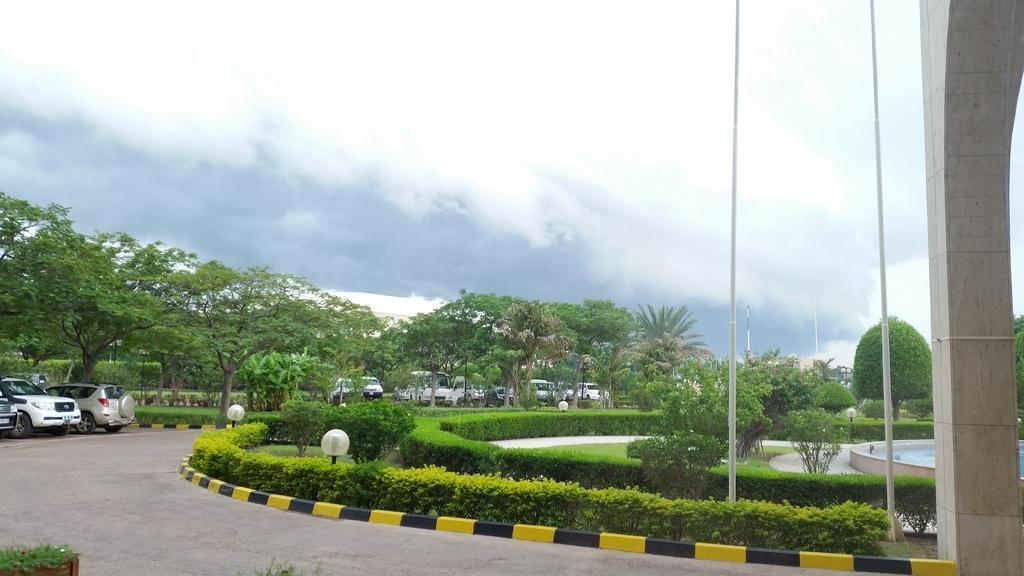Can you describe this image briefly? In this image, we can see some plants and trees. There are cars on the left side of the image. There are poles and pillar on the right side of the image. In the background of the image, there is a sky. 